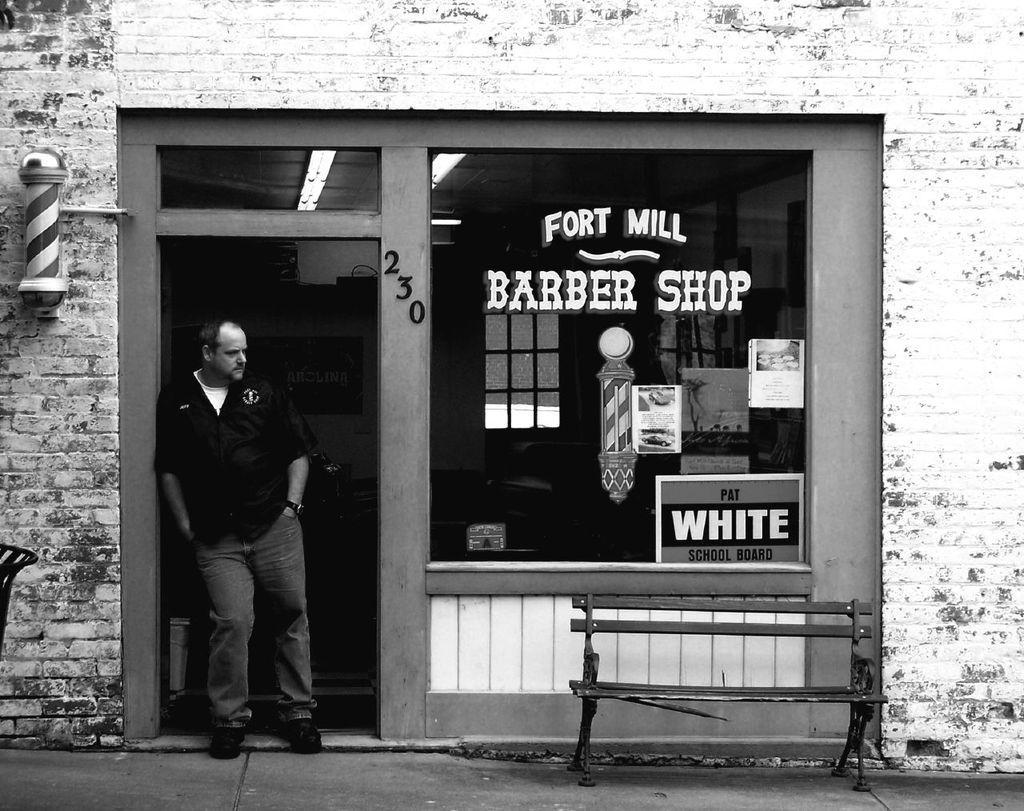Describe this image in one or two sentences. Man standing there is glass,building and bench. 